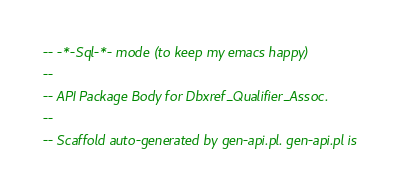Convert code to text. <code><loc_0><loc_0><loc_500><loc_500><_SQL_>-- -*-Sql-*- mode (to keep my emacs happy)
--
-- API Package Body for Dbxref_Qualifier_Assoc.
--
-- Scaffold auto-generated by gen-api.pl. gen-api.pl is</code> 